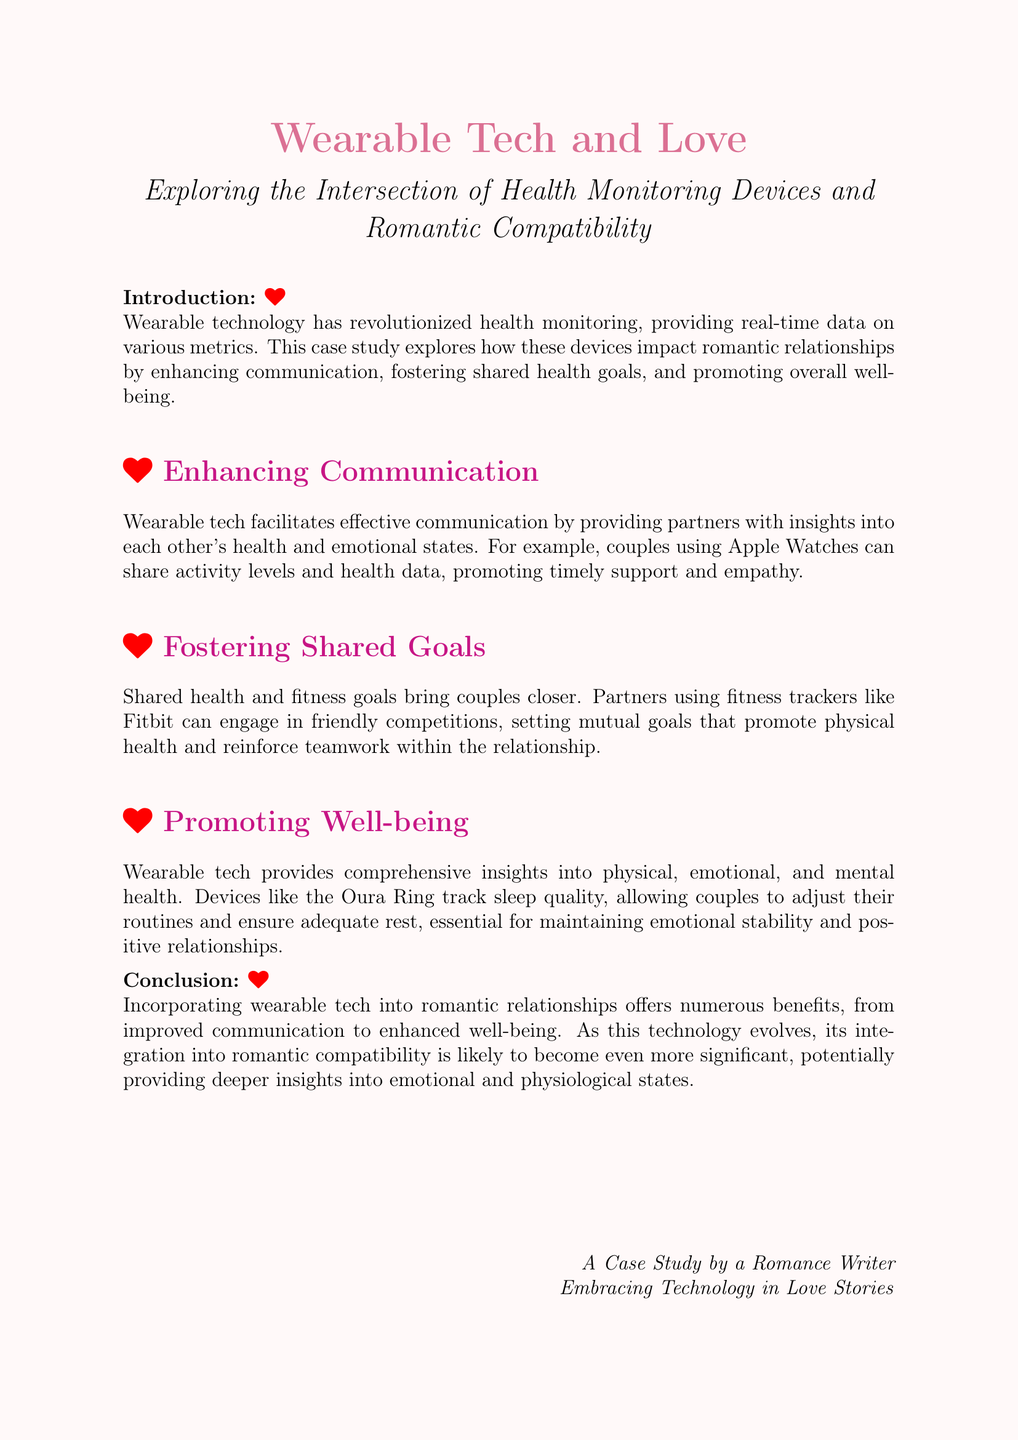what is the title of the case study? The title of the case study is mentioned in the document's header.
Answer: Wearable Tech and Love which technology is mentioned as facilitating communication between partners? The document specifies a couple of example devices used for communication in relationships.
Answer: Apple Watches what is one benefit of fostering shared goals? The document discusses how shared goals impact relationships positively, contributing to teamwork.
Answer: Reinforce teamwork which device is mentioned for tracking sleep quality? The case study provides an example of a specific wearable device used for sleep tracking.
Answer: Oura Ring how does wearable tech promote overall well-being? The document outlines several ways wearable technology contributes to health and relationships.
Answer: Provides comprehensive insights what is a key aspect of the conclusion? The conclusion summarizes the potential future significance of wearable technology in relationships.
Answer: Deeper insights into emotional and physiological states what is the primary focus of this case study? The introduction explains the overarching theme and objective of the case study.
Answer: Intersection of health monitoring devices and romantic compatibility 